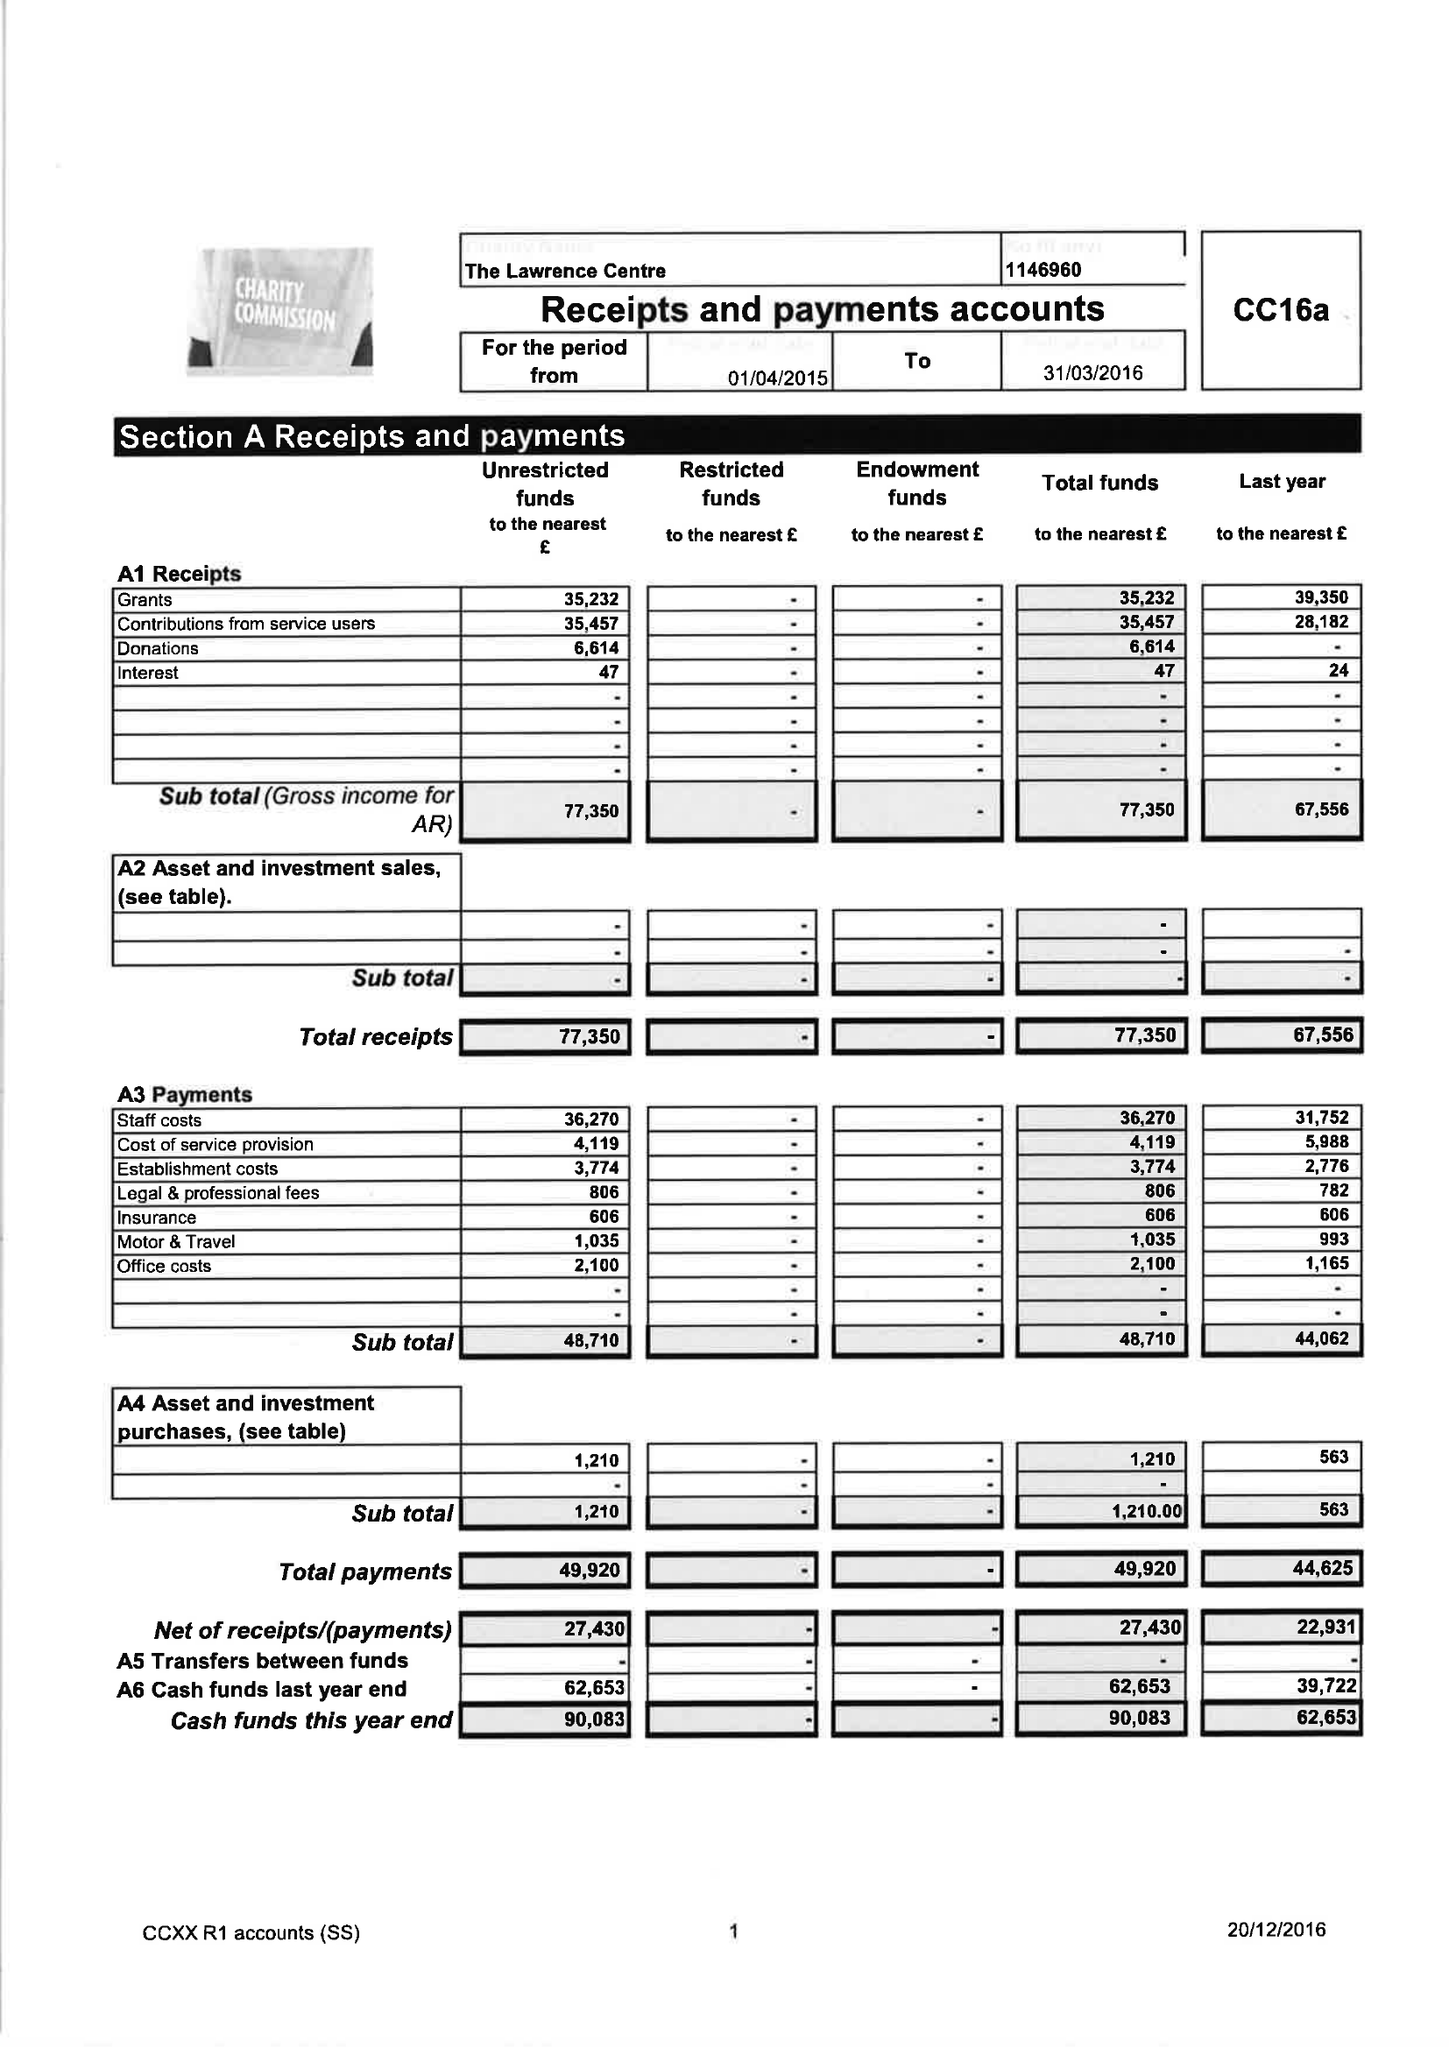What is the value for the income_annually_in_british_pounds?
Answer the question using a single word or phrase. 77350.00 